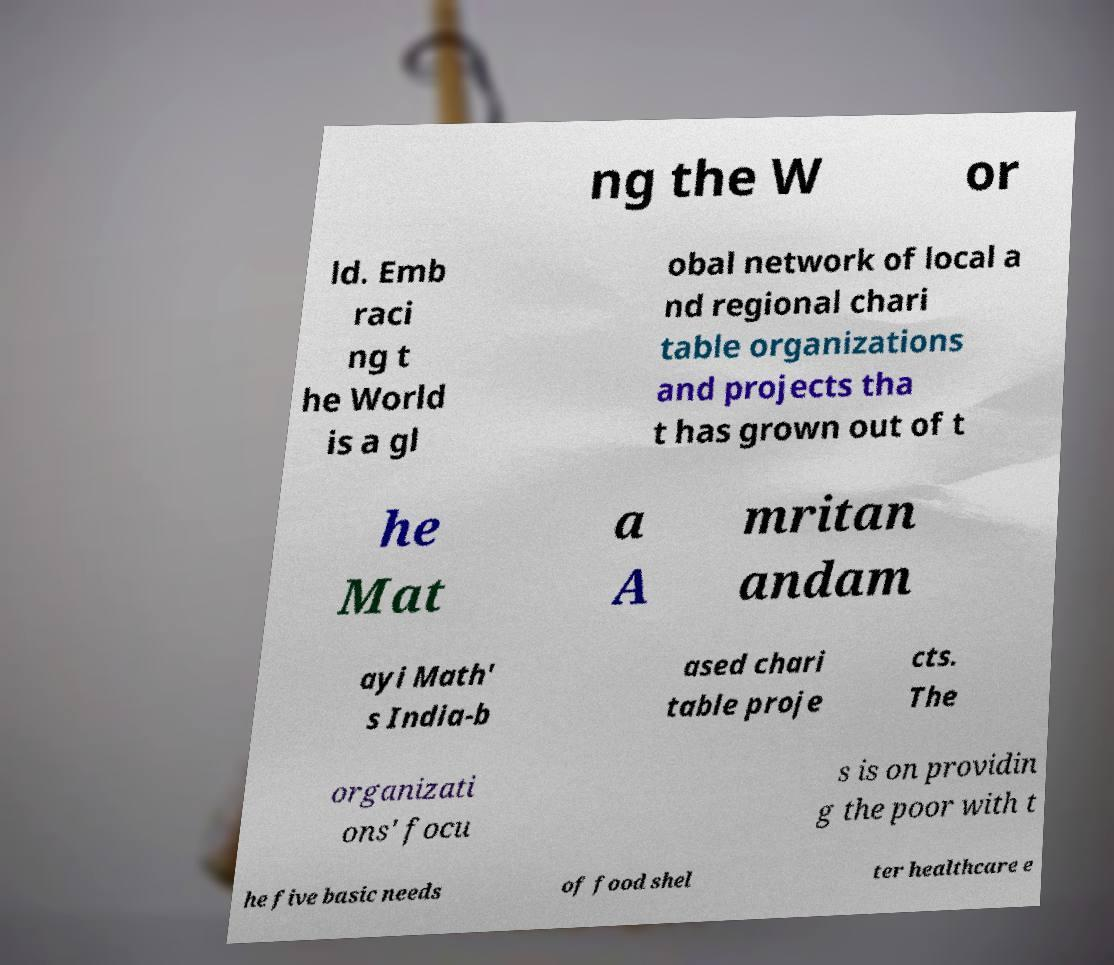Can you read and provide the text displayed in the image?This photo seems to have some interesting text. Can you extract and type it out for me? ng the W or ld. Emb raci ng t he World is a gl obal network of local a nd regional chari table organizations and projects tha t has grown out of t he Mat a A mritan andam ayi Math' s India-b ased chari table proje cts. The organizati ons' focu s is on providin g the poor with t he five basic needs of food shel ter healthcare e 